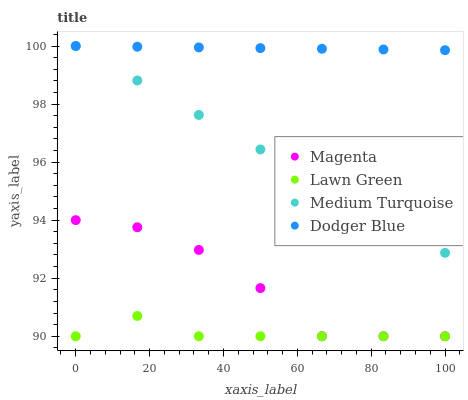Does Lawn Green have the minimum area under the curve?
Answer yes or no. Yes. Does Dodger Blue have the maximum area under the curve?
Answer yes or no. Yes. Does Magenta have the minimum area under the curve?
Answer yes or no. No. Does Magenta have the maximum area under the curve?
Answer yes or no. No. Is Dodger Blue the smoothest?
Answer yes or no. Yes. Is Magenta the roughest?
Answer yes or no. Yes. Is Magenta the smoothest?
Answer yes or no. No. Is Dodger Blue the roughest?
Answer yes or no. No. Does Lawn Green have the lowest value?
Answer yes or no. Yes. Does Dodger Blue have the lowest value?
Answer yes or no. No. Does Medium Turquoise have the highest value?
Answer yes or no. Yes. Does Magenta have the highest value?
Answer yes or no. No. Is Lawn Green less than Medium Turquoise?
Answer yes or no. Yes. Is Medium Turquoise greater than Lawn Green?
Answer yes or no. Yes. Does Magenta intersect Lawn Green?
Answer yes or no. Yes. Is Magenta less than Lawn Green?
Answer yes or no. No. Is Magenta greater than Lawn Green?
Answer yes or no. No. Does Lawn Green intersect Medium Turquoise?
Answer yes or no. No. 